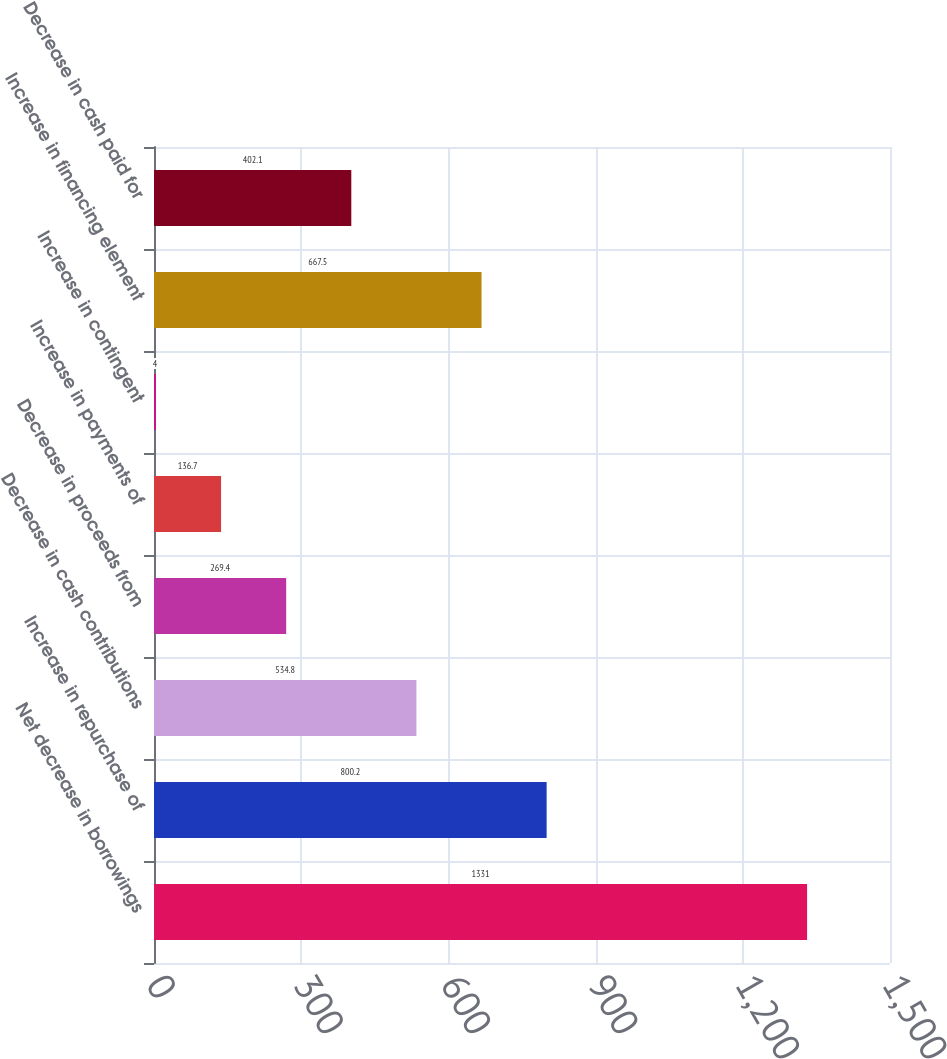<chart> <loc_0><loc_0><loc_500><loc_500><bar_chart><fcel>Net decrease in borrowings<fcel>Increase in repurchase of<fcel>Decrease in cash contributions<fcel>Decrease in proceeds from<fcel>Increase in payments of<fcel>Increase in contingent<fcel>Increase in financing element<fcel>Decrease in cash paid for<nl><fcel>1331<fcel>800.2<fcel>534.8<fcel>269.4<fcel>136.7<fcel>4<fcel>667.5<fcel>402.1<nl></chart> 